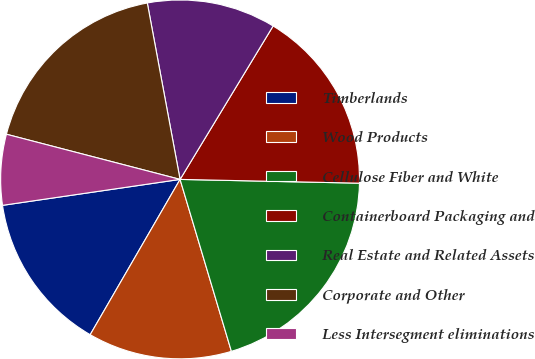Convert chart to OTSL. <chart><loc_0><loc_0><loc_500><loc_500><pie_chart><fcel>Timberlands<fcel>Wood Products<fcel>Cellulose Fiber and White<fcel>Containerboard Packaging and<fcel>Real Estate and Related Assets<fcel>Corporate and Other<fcel>Less Intersegment eliminations<nl><fcel>14.34%<fcel>12.97%<fcel>20.05%<fcel>16.66%<fcel>11.6%<fcel>18.03%<fcel>6.36%<nl></chart> 